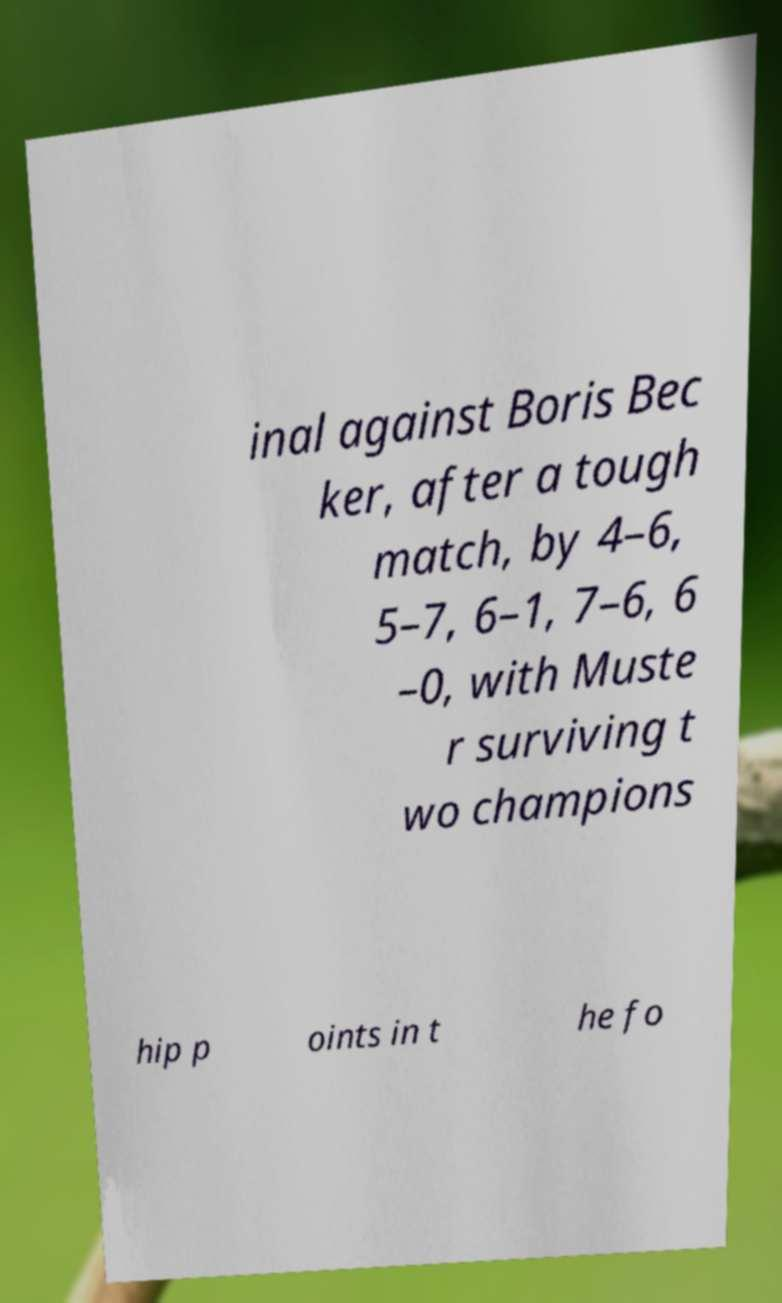Can you read and provide the text displayed in the image?This photo seems to have some interesting text. Can you extract and type it out for me? inal against Boris Bec ker, after a tough match, by 4–6, 5–7, 6–1, 7–6, 6 –0, with Muste r surviving t wo champions hip p oints in t he fo 